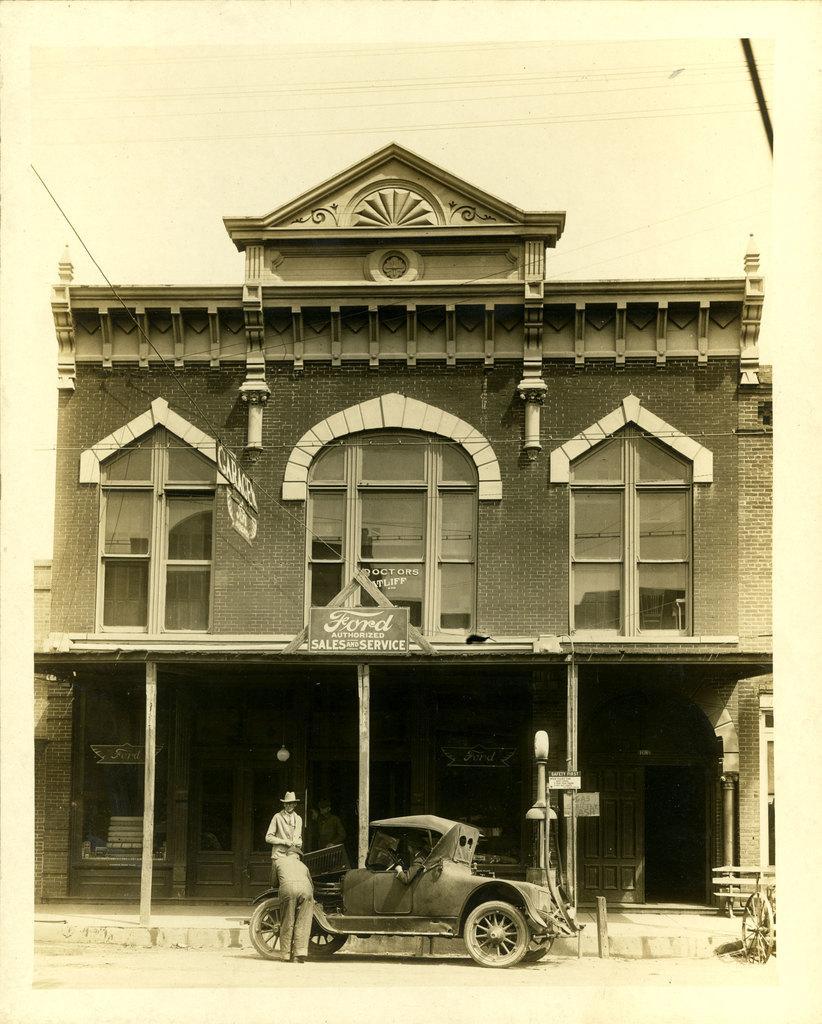Can you describe this image briefly? In this image there are 2 persons near a car ,and background there is a building , name board , sky. 